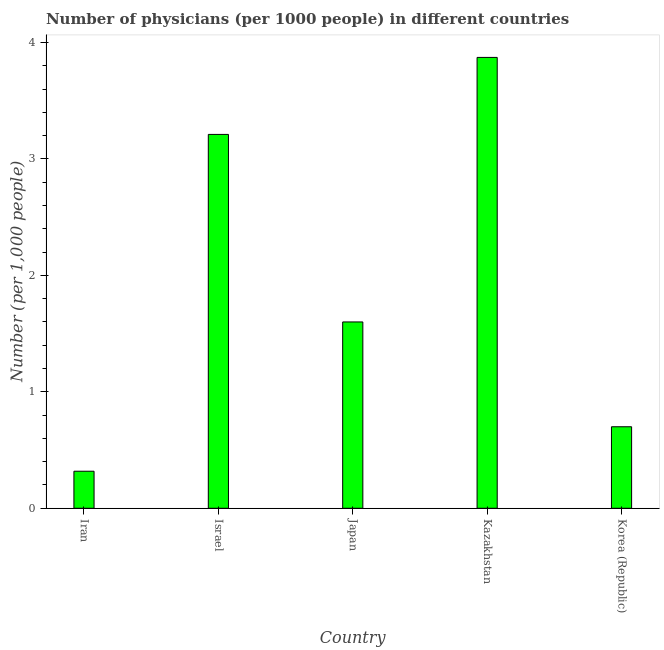Does the graph contain any zero values?
Give a very brief answer. No. What is the title of the graph?
Your answer should be compact. Number of physicians (per 1000 people) in different countries. What is the label or title of the X-axis?
Provide a succinct answer. Country. What is the label or title of the Y-axis?
Offer a terse response. Number (per 1,0 people). What is the number of physicians in Israel?
Provide a short and direct response. 3.21. Across all countries, what is the maximum number of physicians?
Your response must be concise. 3.87. Across all countries, what is the minimum number of physicians?
Keep it short and to the point. 0.32. In which country was the number of physicians maximum?
Your answer should be compact. Kazakhstan. In which country was the number of physicians minimum?
Keep it short and to the point. Iran. What is the sum of the number of physicians?
Provide a succinct answer. 9.7. What is the difference between the number of physicians in Japan and Korea (Republic)?
Offer a terse response. 0.9. What is the average number of physicians per country?
Ensure brevity in your answer.  1.94. What is the median number of physicians?
Make the answer very short. 1.6. In how many countries, is the number of physicians greater than 3.8 ?
Your response must be concise. 1. What is the ratio of the number of physicians in Japan to that in Kazakhstan?
Make the answer very short. 0.41. Is the number of physicians in Iran less than that in Korea (Republic)?
Your answer should be very brief. Yes. Is the difference between the number of physicians in Japan and Korea (Republic) greater than the difference between any two countries?
Give a very brief answer. No. What is the difference between the highest and the second highest number of physicians?
Keep it short and to the point. 0.66. Is the sum of the number of physicians in Israel and Japan greater than the maximum number of physicians across all countries?
Provide a succinct answer. Yes. What is the difference between the highest and the lowest number of physicians?
Your answer should be very brief. 3.55. In how many countries, is the number of physicians greater than the average number of physicians taken over all countries?
Your answer should be compact. 2. How many bars are there?
Your answer should be very brief. 5. What is the difference between two consecutive major ticks on the Y-axis?
Offer a terse response. 1. What is the Number (per 1,000 people) of Iran?
Ensure brevity in your answer.  0.32. What is the Number (per 1,000 people) in Israel?
Offer a terse response. 3.21. What is the Number (per 1,000 people) of Kazakhstan?
Ensure brevity in your answer.  3.87. What is the difference between the Number (per 1,000 people) in Iran and Israel?
Ensure brevity in your answer.  -2.89. What is the difference between the Number (per 1,000 people) in Iran and Japan?
Your answer should be compact. -1.28. What is the difference between the Number (per 1,000 people) in Iran and Kazakhstan?
Make the answer very short. -3.55. What is the difference between the Number (per 1,000 people) in Iran and Korea (Republic)?
Ensure brevity in your answer.  -0.38. What is the difference between the Number (per 1,000 people) in Israel and Japan?
Your answer should be compact. 1.61. What is the difference between the Number (per 1,000 people) in Israel and Kazakhstan?
Make the answer very short. -0.66. What is the difference between the Number (per 1,000 people) in Israel and Korea (Republic)?
Your answer should be compact. 2.51. What is the difference between the Number (per 1,000 people) in Japan and Kazakhstan?
Ensure brevity in your answer.  -2.27. What is the difference between the Number (per 1,000 people) in Kazakhstan and Korea (Republic)?
Keep it short and to the point. 3.17. What is the ratio of the Number (per 1,000 people) in Iran to that in Israel?
Keep it short and to the point. 0.1. What is the ratio of the Number (per 1,000 people) in Iran to that in Japan?
Keep it short and to the point. 0.2. What is the ratio of the Number (per 1,000 people) in Iran to that in Kazakhstan?
Your response must be concise. 0.08. What is the ratio of the Number (per 1,000 people) in Iran to that in Korea (Republic)?
Your answer should be very brief. 0.45. What is the ratio of the Number (per 1,000 people) in Israel to that in Japan?
Give a very brief answer. 2.01. What is the ratio of the Number (per 1,000 people) in Israel to that in Kazakhstan?
Ensure brevity in your answer.  0.83. What is the ratio of the Number (per 1,000 people) in Israel to that in Korea (Republic)?
Your answer should be very brief. 4.59. What is the ratio of the Number (per 1,000 people) in Japan to that in Kazakhstan?
Your response must be concise. 0.41. What is the ratio of the Number (per 1,000 people) in Japan to that in Korea (Republic)?
Provide a succinct answer. 2.29. What is the ratio of the Number (per 1,000 people) in Kazakhstan to that in Korea (Republic)?
Keep it short and to the point. 5.53. 